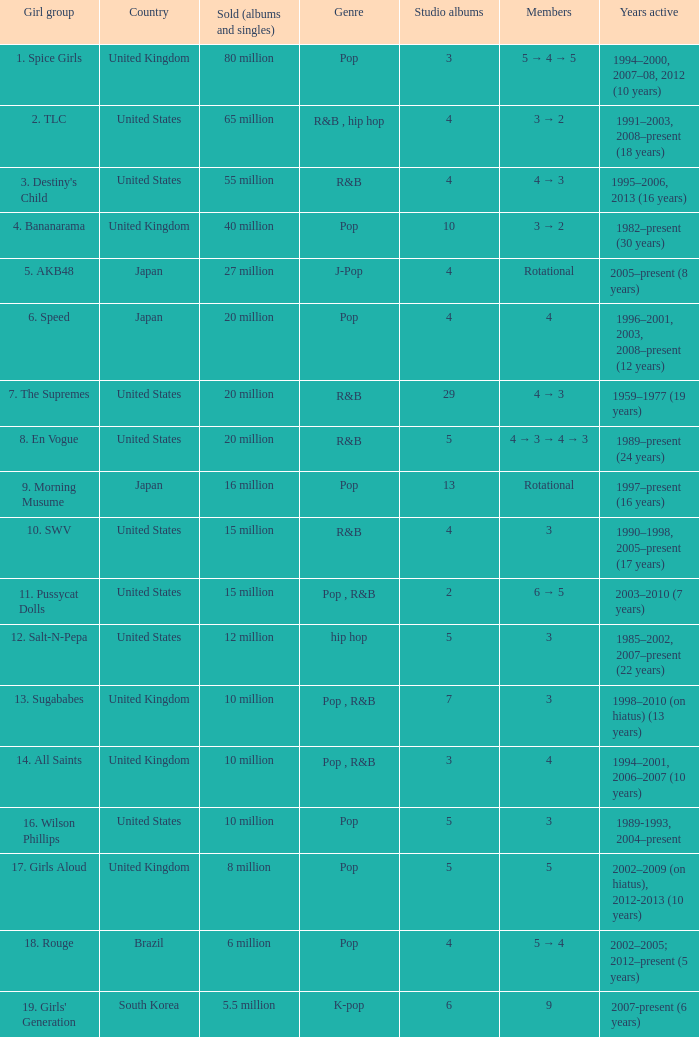What group had 29 studio albums? 7. The Supremes. 